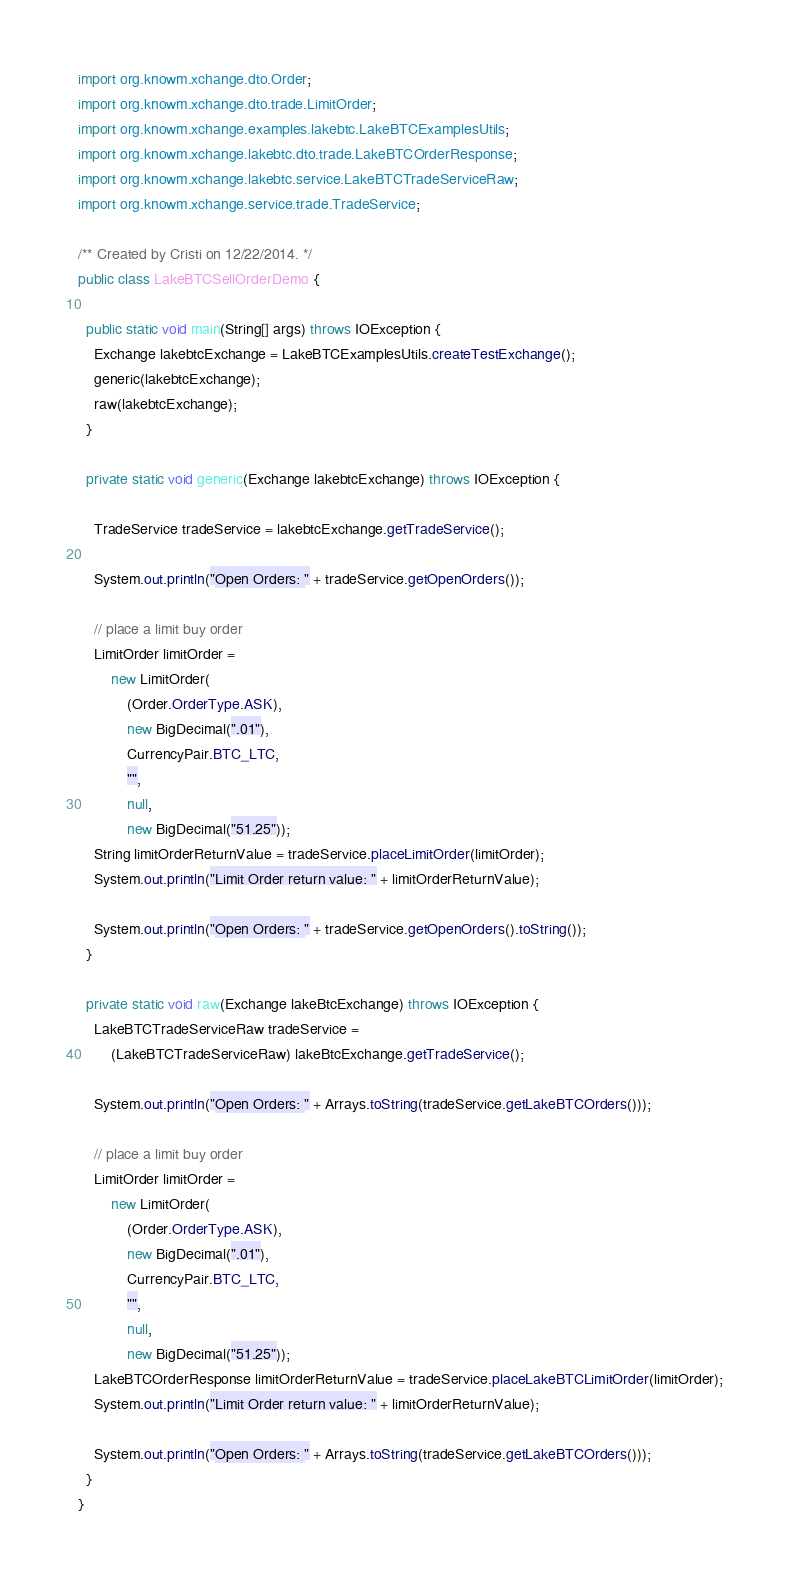Convert code to text. <code><loc_0><loc_0><loc_500><loc_500><_Java_>import org.knowm.xchange.dto.Order;
import org.knowm.xchange.dto.trade.LimitOrder;
import org.knowm.xchange.examples.lakebtc.LakeBTCExamplesUtils;
import org.knowm.xchange.lakebtc.dto.trade.LakeBTCOrderResponse;
import org.knowm.xchange.lakebtc.service.LakeBTCTradeServiceRaw;
import org.knowm.xchange.service.trade.TradeService;

/** Created by Cristi on 12/22/2014. */
public class LakeBTCSellOrderDemo {

  public static void main(String[] args) throws IOException {
    Exchange lakebtcExchange = LakeBTCExamplesUtils.createTestExchange();
    generic(lakebtcExchange);
    raw(lakebtcExchange);
  }

  private static void generic(Exchange lakebtcExchange) throws IOException {

    TradeService tradeService = lakebtcExchange.getTradeService();

    System.out.println("Open Orders: " + tradeService.getOpenOrders());

    // place a limit buy order
    LimitOrder limitOrder =
        new LimitOrder(
            (Order.OrderType.ASK),
            new BigDecimal(".01"),
            CurrencyPair.BTC_LTC,
            "",
            null,
            new BigDecimal("51.25"));
    String limitOrderReturnValue = tradeService.placeLimitOrder(limitOrder);
    System.out.println("Limit Order return value: " + limitOrderReturnValue);

    System.out.println("Open Orders: " + tradeService.getOpenOrders().toString());
  }

  private static void raw(Exchange lakeBtcExchange) throws IOException {
    LakeBTCTradeServiceRaw tradeService =
        (LakeBTCTradeServiceRaw) lakeBtcExchange.getTradeService();

    System.out.println("Open Orders: " + Arrays.toString(tradeService.getLakeBTCOrders()));

    // place a limit buy order
    LimitOrder limitOrder =
        new LimitOrder(
            (Order.OrderType.ASK),
            new BigDecimal(".01"),
            CurrencyPair.BTC_LTC,
            "",
            null,
            new BigDecimal("51.25"));
    LakeBTCOrderResponse limitOrderReturnValue = tradeService.placeLakeBTCLimitOrder(limitOrder);
    System.out.println("Limit Order return value: " + limitOrderReturnValue);

    System.out.println("Open Orders: " + Arrays.toString(tradeService.getLakeBTCOrders()));
  }
}
</code> 